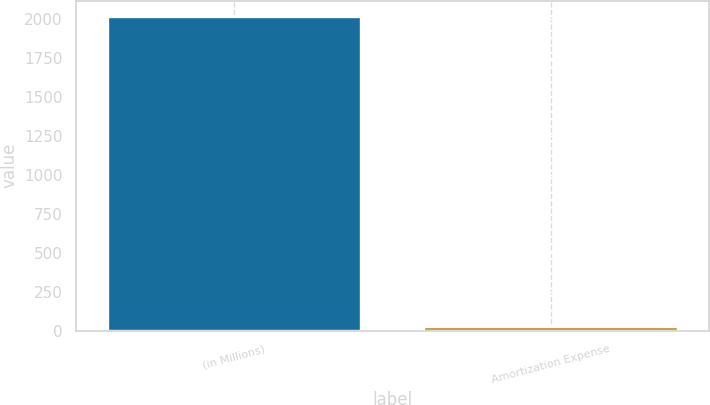Convert chart to OTSL. <chart><loc_0><loc_0><loc_500><loc_500><bar_chart><fcel>(in Millions)<fcel>Amortization Expense<nl><fcel>2015<fcel>22.7<nl></chart> 